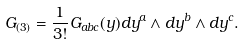Convert formula to latex. <formula><loc_0><loc_0><loc_500><loc_500>G _ { ( 3 ) } = \frac { 1 } { 3 ! } G _ { a b c } ( y ) d y ^ { a } \wedge d y ^ { b } \wedge d y ^ { c } .</formula> 